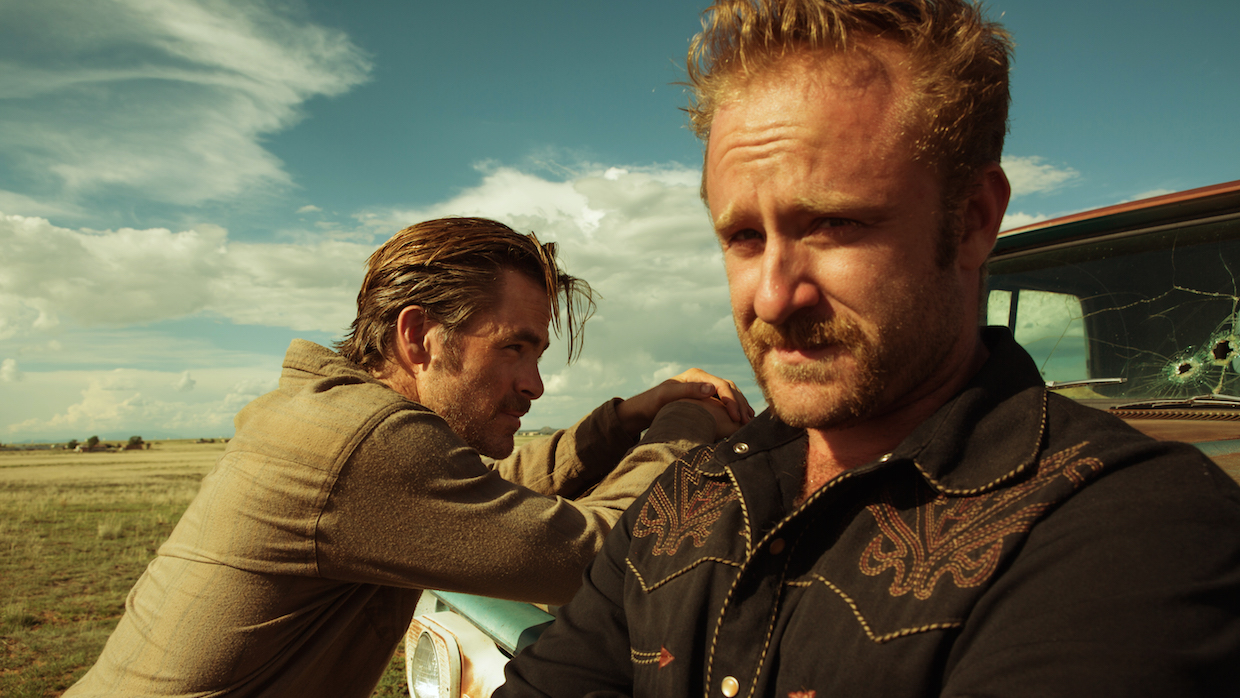What do you think is going on in this snapshot? In the image, actor Ben Foster, known for his role as Tanner Howard in the film "Hell or High Water," is depicted in a moment of intense focus. He stands beside an old car with a cracked windshield, suggesting a scene of violence or escape. His disheveled hair and rugged appearance add to the gritty atmosphere of the scene. His black shirt, adorned with an intricate design, adds a layer of detail to his character. In the background, slightly blurred but still noticeable, is his co-star Chris Pine, casually leaning against the car, adding to the tension and intrigue of the moment, likely indicative of a pivotal scene in the film. 